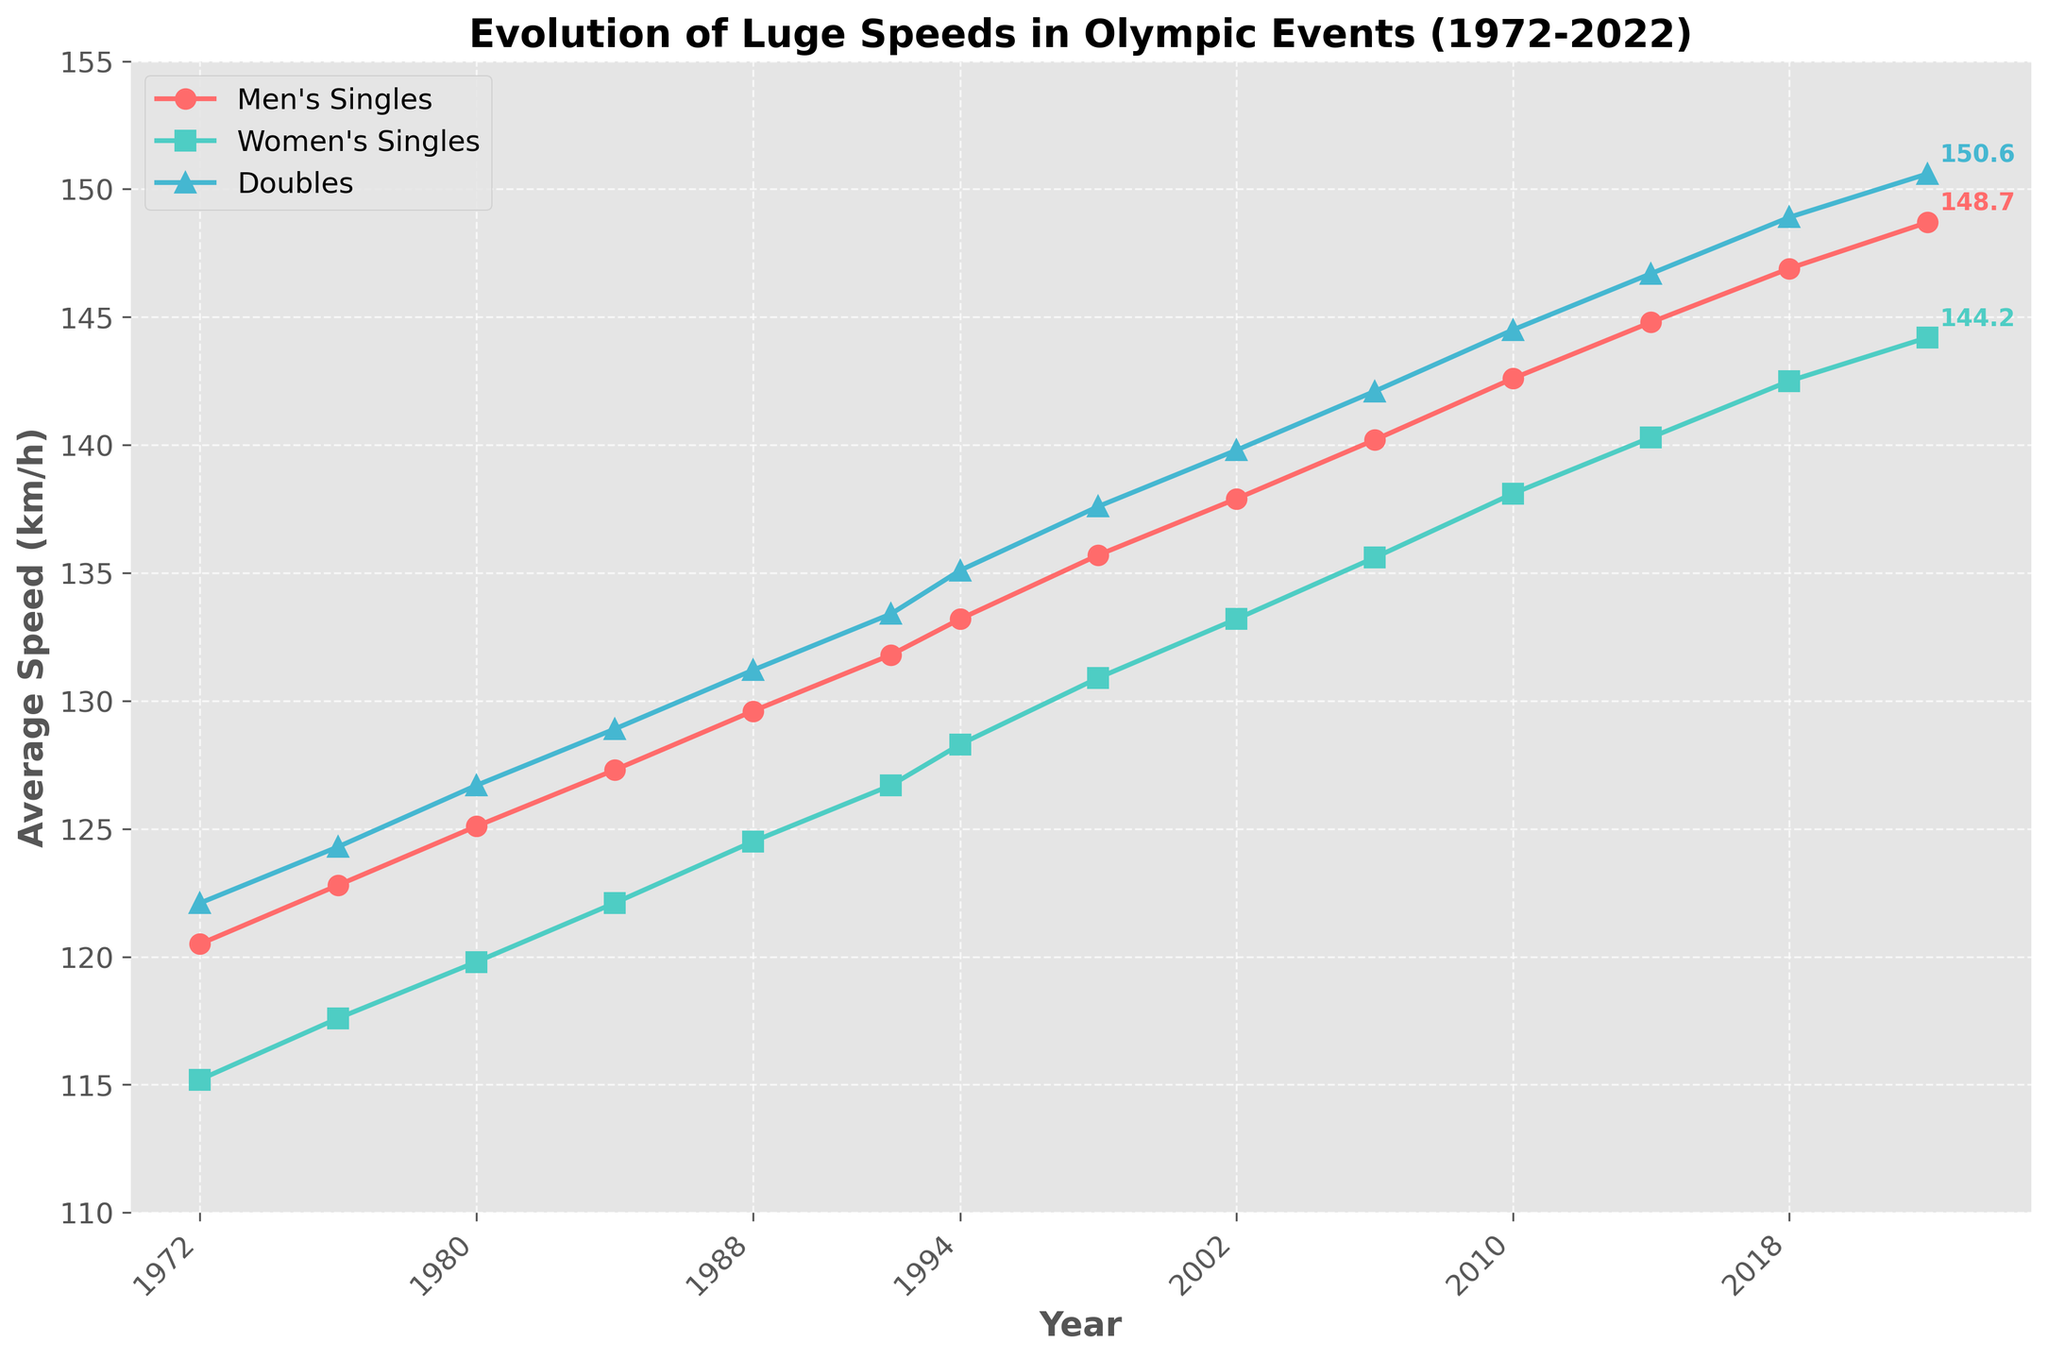What are the average speeds for Men's Singles, Women's Singles, and Doubles in the year 2022? Look at the data points for the year 2022 on each of the three lines: the Men's Singles (red line), Women's Singles (green line), and Doubles (blue line). Note their respective values.
Answer: 148.7 km/h, 144.2 km/h, 150.6 km/h Which category saw the highest average speed in 2014? Compare the data points for Men's Singles, Women's Singles, and Doubles in 2014. The highest value among them is the highest average speed.
Answer: Doubles How much did the average speed of Women's Singles increase from 1972 to 2022? Subtract the Women's Singles speed in 1972 from the Women's Singles speed in 2022, i.e., 144.2 km/h - 115.2 km/h.
Answer: 29 km/h By how much did the average speed difference between Men's Singles and Women's Singles change from 1980 to 2000? Calculate the speed difference for Men's Singles and Women's Singles in 1980 (125.1 km/h - 119.8 km/h) and 2000 (137.9 km/h - 133.2 km/h). Then, find the difference between these two values.
Answer: 0.4 km/h Which category experienced the least increase in their average speed from 1972 to 2022? Compute the increase for Men's Singles (148.7 km/h - 120.5 km/h), Women's Singles (144.2 km/h - 115.2 km/h), and Doubles (150.6 km/h - 122.1 km/h), then compare these increases to find the smallest one.
Answer: Women's Singles What is the median average speed for Men's Singles from 1972 to 2022? Arrange the Men's Singles speeds in ascending order and find the middle value. Since there are 14 data points, the median will be the average of the 7th and 8th values.
Answer: 135.7 km/h How does the trend of average speeds for Doubles compare to that of Men's Singles over the years? Observe the slope and pattern of the Doubles (blue line) and Men's Singles (red line). Note similarities or differences in their trends.
Answer: Both are increasing but Doubles generally have higher speeds In which year did the average speed for Men's Singles and Doubles have the smallest difference? Calculate the speed difference between Men's Singles and Doubles for each displayed year and determine the minimum value.
Answer: 1976 What visual cues distinguish the lines representing Men's Singles, Women's Singles, and Doubles on the plot? Identify the shapes and colors of the markers and lines for each category: Men's Singles uses circles and is red, Women's Singles uses squares and is green, Doubles uses triangles and is blue.
Answer: Different markers and colors Which category had the most consistent increase in average speed over the years? Analyze the slope consistency of all three lines across the years; the line with the most uniform slope reflects consistency.
Answer: Women's Singles 